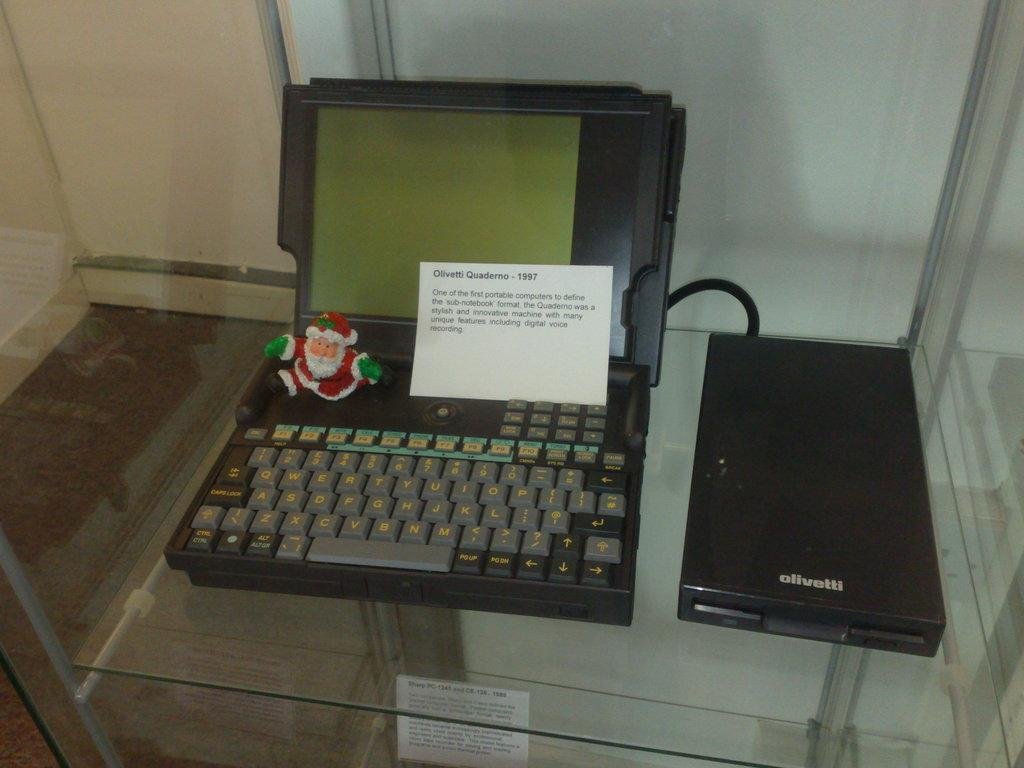<image>
Share a concise interpretation of the image provided. An open laptop is sitting on a glass table with an olivetti drive attached. 